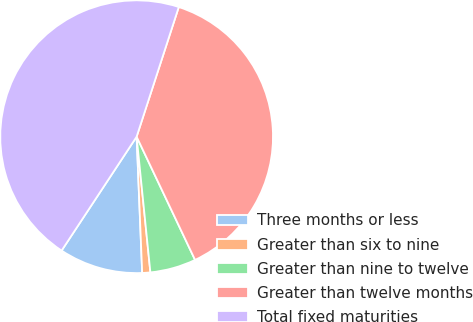<chart> <loc_0><loc_0><loc_500><loc_500><pie_chart><fcel>Three months or less<fcel>Greater than six to nine<fcel>Greater than nine to twelve<fcel>Greater than twelve months<fcel>Total fixed maturities<nl><fcel>9.92%<fcel>0.96%<fcel>5.44%<fcel>37.95%<fcel>45.73%<nl></chart> 